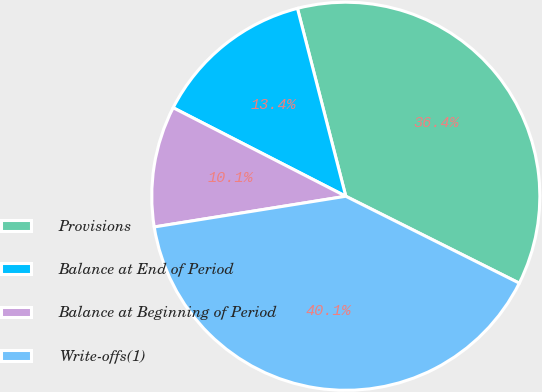Convert chart to OTSL. <chart><loc_0><loc_0><loc_500><loc_500><pie_chart><fcel>Provisions<fcel>Balance at End of Period<fcel>Balance at Beginning of Period<fcel>Write-offs(1)<nl><fcel>36.4%<fcel>13.45%<fcel>10.07%<fcel>40.08%<nl></chart> 